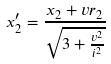<formula> <loc_0><loc_0><loc_500><loc_500>x _ { 2 } ^ { \prime } = \frac { x _ { 2 } + v r _ { 2 } } { \sqrt { 3 + \frac { v ^ { 2 } } { i ^ { 2 } } } }</formula> 